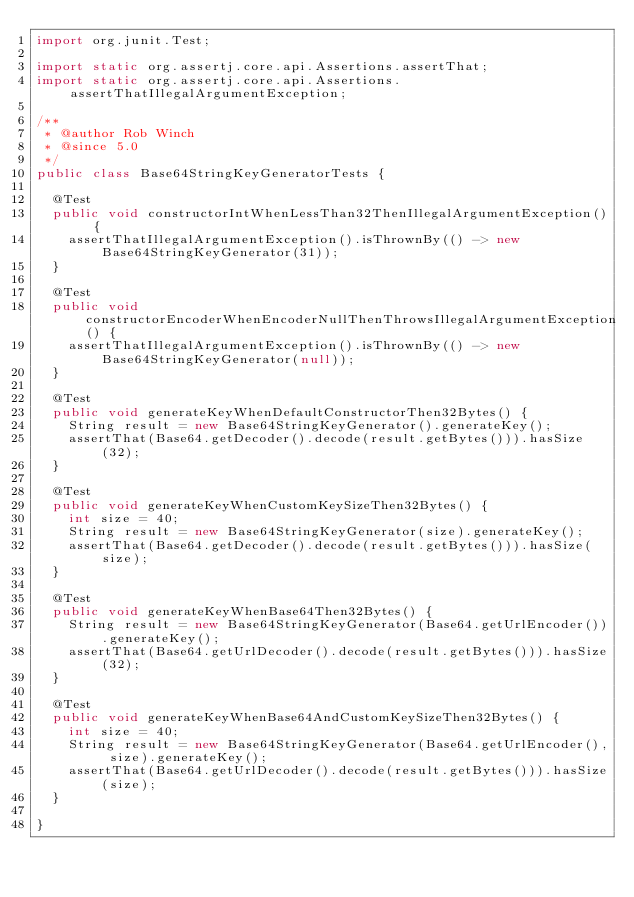Convert code to text. <code><loc_0><loc_0><loc_500><loc_500><_Java_>import org.junit.Test;

import static org.assertj.core.api.Assertions.assertThat;
import static org.assertj.core.api.Assertions.assertThatIllegalArgumentException;

/**
 * @author Rob Winch
 * @since 5.0
 */
public class Base64StringKeyGeneratorTests {

	@Test
	public void constructorIntWhenLessThan32ThenIllegalArgumentException() {
		assertThatIllegalArgumentException().isThrownBy(() -> new Base64StringKeyGenerator(31));
	}

	@Test
	public void constructorEncoderWhenEncoderNullThenThrowsIllegalArgumentException() {
		assertThatIllegalArgumentException().isThrownBy(() -> new Base64StringKeyGenerator(null));
	}

	@Test
	public void generateKeyWhenDefaultConstructorThen32Bytes() {
		String result = new Base64StringKeyGenerator().generateKey();
		assertThat(Base64.getDecoder().decode(result.getBytes())).hasSize(32);
	}

	@Test
	public void generateKeyWhenCustomKeySizeThen32Bytes() {
		int size = 40;
		String result = new Base64StringKeyGenerator(size).generateKey();
		assertThat(Base64.getDecoder().decode(result.getBytes())).hasSize(size);
	}

	@Test
	public void generateKeyWhenBase64Then32Bytes() {
		String result = new Base64StringKeyGenerator(Base64.getUrlEncoder()).generateKey();
		assertThat(Base64.getUrlDecoder().decode(result.getBytes())).hasSize(32);
	}

	@Test
	public void generateKeyWhenBase64AndCustomKeySizeThen32Bytes() {
		int size = 40;
		String result = new Base64StringKeyGenerator(Base64.getUrlEncoder(), size).generateKey();
		assertThat(Base64.getUrlDecoder().decode(result.getBytes())).hasSize(size);
	}

}
</code> 